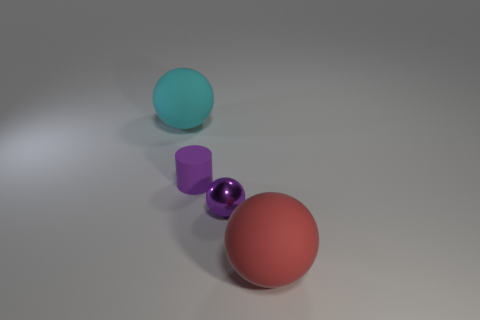How many other things are the same size as the cyan ball?
Your answer should be very brief. 1. There is a purple thing that is the same shape as the red rubber thing; what material is it?
Provide a succinct answer. Metal. There is a big thing behind the matte ball that is to the right of the big thing behind the big red rubber object; what is its material?
Ensure brevity in your answer.  Rubber. What is the size of the cylinder that is made of the same material as the cyan sphere?
Provide a short and direct response. Small. There is a small object right of the small purple rubber thing; is it the same color as the small thing on the left side of the tiny purple shiny object?
Your response must be concise. Yes. What color is the large thing in front of the cyan sphere?
Offer a very short reply. Red. Is the size of the rubber ball that is behind the red rubber ball the same as the red thing?
Offer a very short reply. Yes. Are there fewer purple cylinders than purple things?
Your answer should be very brief. Yes. The object that is the same color as the small metallic ball is what shape?
Offer a very short reply. Cylinder. What number of purple cylinders are to the left of the cylinder?
Provide a succinct answer. 0. 